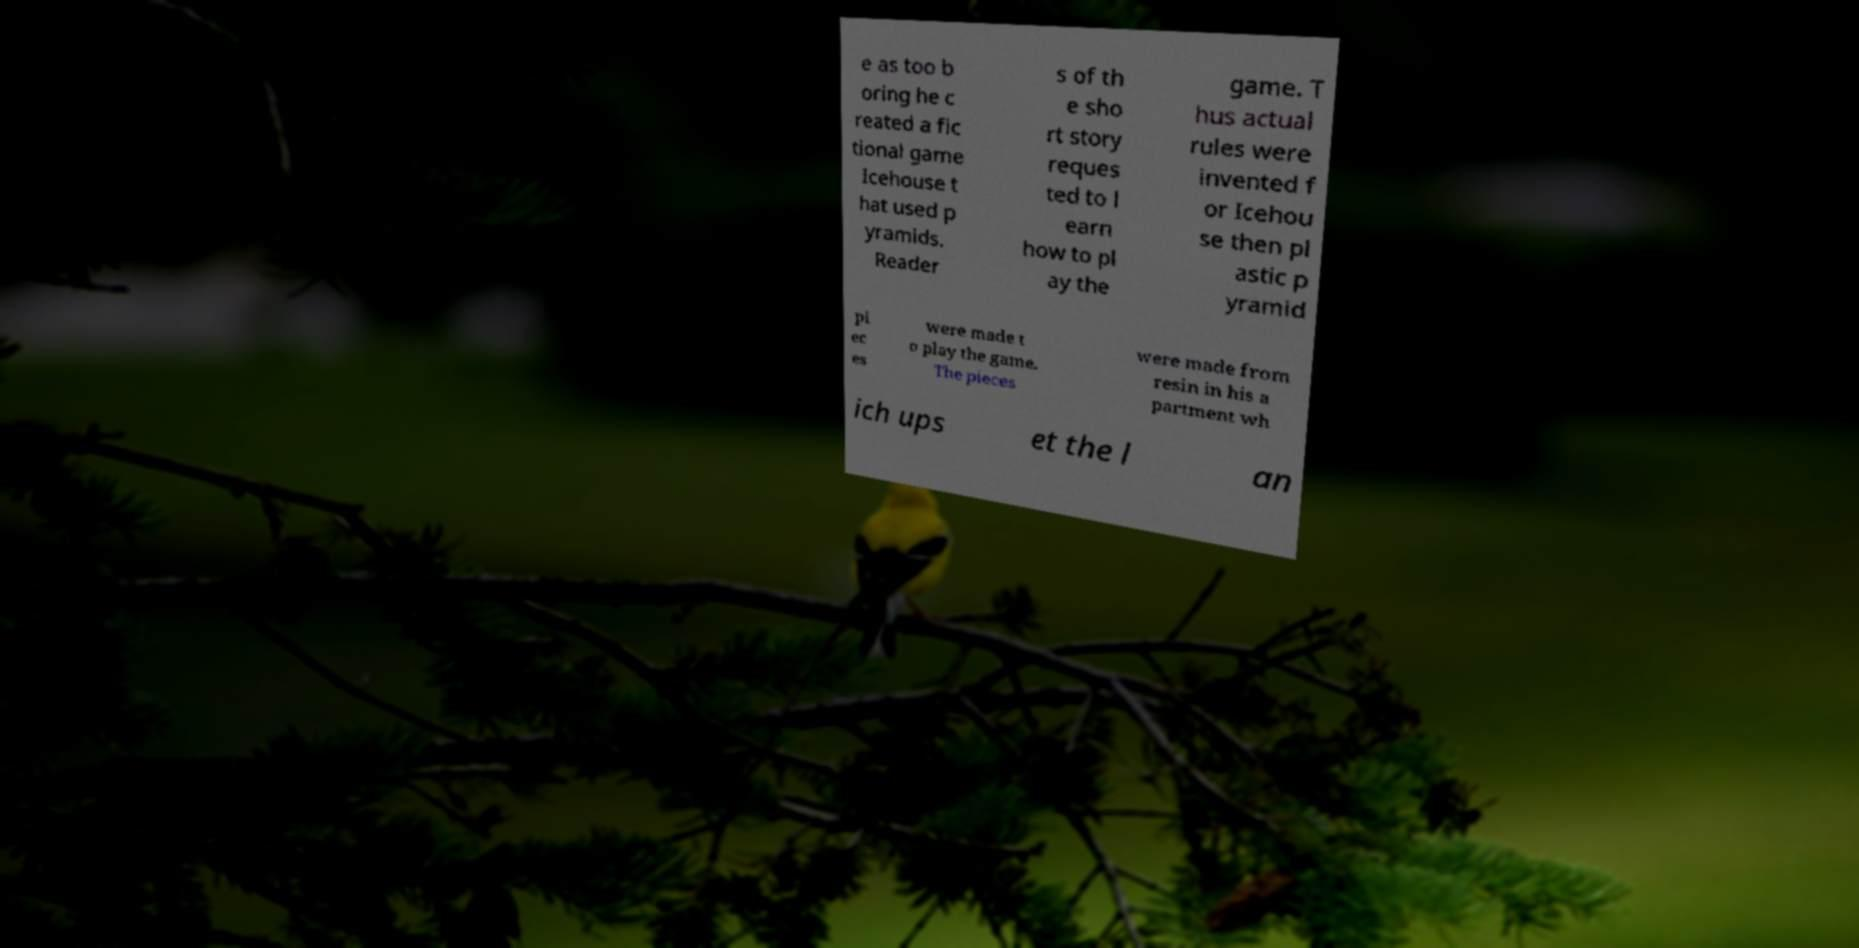What messages or text are displayed in this image? I need them in a readable, typed format. e as too b oring he c reated a fic tional game Icehouse t hat used p yramids. Reader s of th e sho rt story reques ted to l earn how to pl ay the game. T hus actual rules were invented f or Icehou se then pl astic p yramid pi ec es were made t o play the game. The pieces were made from resin in his a partment wh ich ups et the l an 